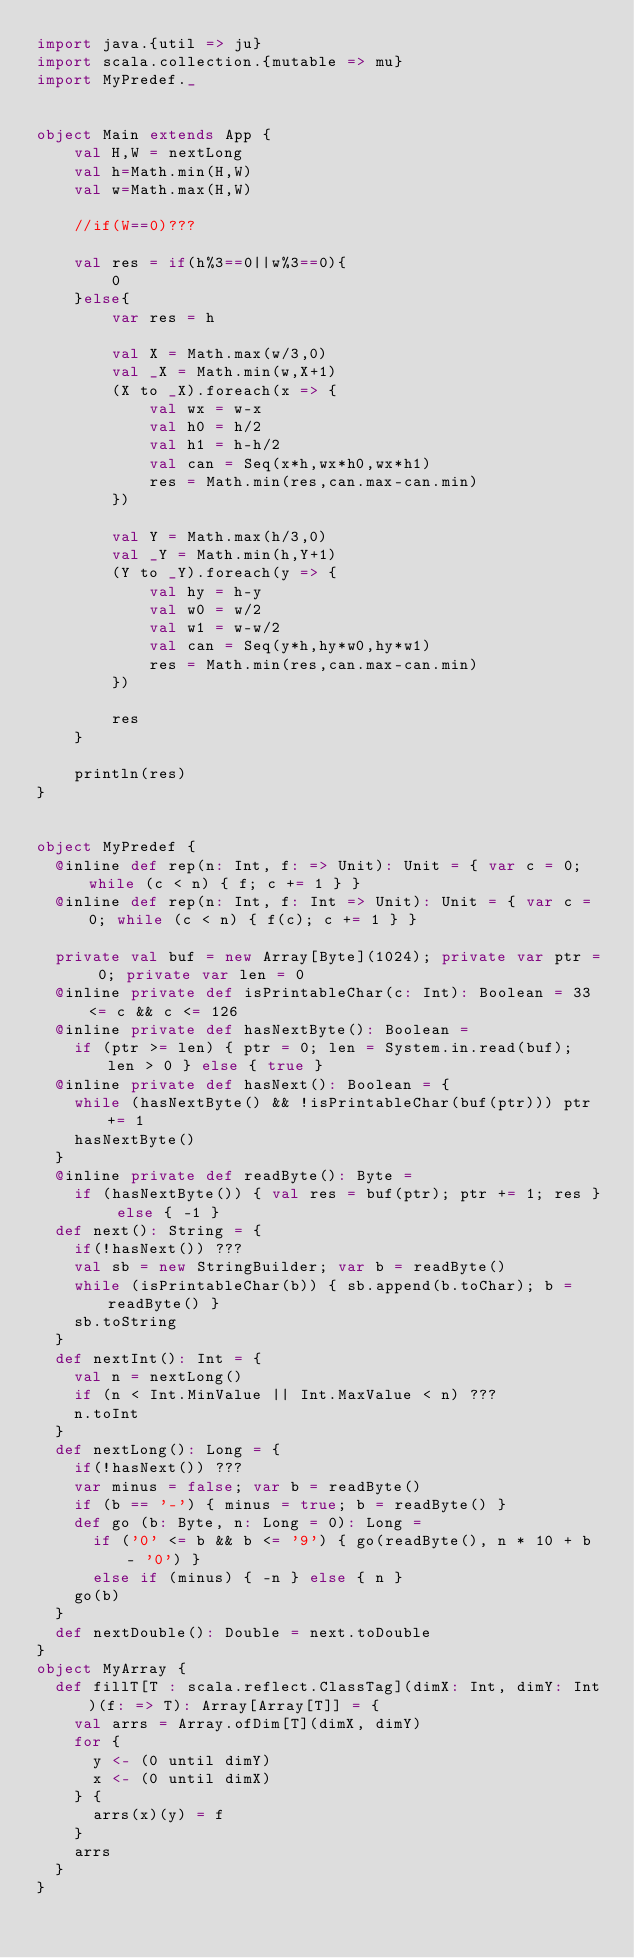Convert code to text. <code><loc_0><loc_0><loc_500><loc_500><_Scala_>import java.{util => ju}
import scala.collection.{mutable => mu}
import MyPredef._


object Main extends App {
    val H,W = nextLong
    val h=Math.min(H,W)
    val w=Math.max(H,W)
    
    //if(W==0)???
    
    val res = if(h%3==0||w%3==0){
        0
    }else{
        var res = h
        
        val X = Math.max(w/3,0)
        val _X = Math.min(w,X+1)
        (X to _X).foreach(x => {
            val wx = w-x
            val h0 = h/2
            val h1 = h-h/2
            val can = Seq(x*h,wx*h0,wx*h1)
            res = Math.min(res,can.max-can.min)
        })
        
        val Y = Math.max(h/3,0)
        val _Y = Math.min(h,Y+1)
        (Y to _Y).foreach(y => {
            val hy = h-y
            val w0 = w/2
            val w1 = w-w/2
            val can = Seq(y*h,hy*w0,hy*w1)
            res = Math.min(res,can.max-can.min)
        })
        
        res
    }
    
    println(res)
}


object MyPredef {
  @inline def rep(n: Int, f: => Unit): Unit = { var c = 0; while (c < n) { f; c += 1 } }
  @inline def rep(n: Int, f: Int => Unit): Unit = { var c = 0; while (c < n) { f(c); c += 1 } }

  private val buf = new Array[Byte](1024); private var ptr = 0; private var len = 0
  @inline private def isPrintableChar(c: Int): Boolean = 33 <= c && c <= 126
  @inline private def hasNextByte(): Boolean =
    if (ptr >= len) { ptr = 0; len = System.in.read(buf); len > 0 } else { true }
  @inline private def hasNext(): Boolean = {
    while (hasNextByte() && !isPrintableChar(buf(ptr))) ptr += 1
    hasNextByte()
  }
  @inline private def readByte(): Byte =
    if (hasNextByte()) { val res = buf(ptr); ptr += 1; res } else { -1 }
  def next(): String = {
    if(!hasNext()) ???
    val sb = new StringBuilder; var b = readByte()
    while (isPrintableChar(b)) { sb.append(b.toChar); b = readByte() }
    sb.toString
  }
  def nextInt(): Int = {
    val n = nextLong()
    if (n < Int.MinValue || Int.MaxValue < n) ???
    n.toInt
  }
  def nextLong(): Long = {
    if(!hasNext()) ???
    var minus = false; var b = readByte()
    if (b == '-') { minus = true; b = readByte() }
    def go (b: Byte, n: Long = 0): Long =
      if ('0' <= b && b <= '9') { go(readByte(), n * 10 + b - '0') }
      else if (minus) { -n } else { n }
    go(b)
  }
  def nextDouble(): Double = next.toDouble
}
object MyArray {
  def fillT[T : scala.reflect.ClassTag](dimX: Int, dimY: Int)(f: => T): Array[Array[T]] = {
    val arrs = Array.ofDim[T](dimX, dimY)
    for {
      y <- (0 until dimY)
      x <- (0 until dimX)
    } {
      arrs(x)(y) = f
    }
    arrs
  }
}</code> 